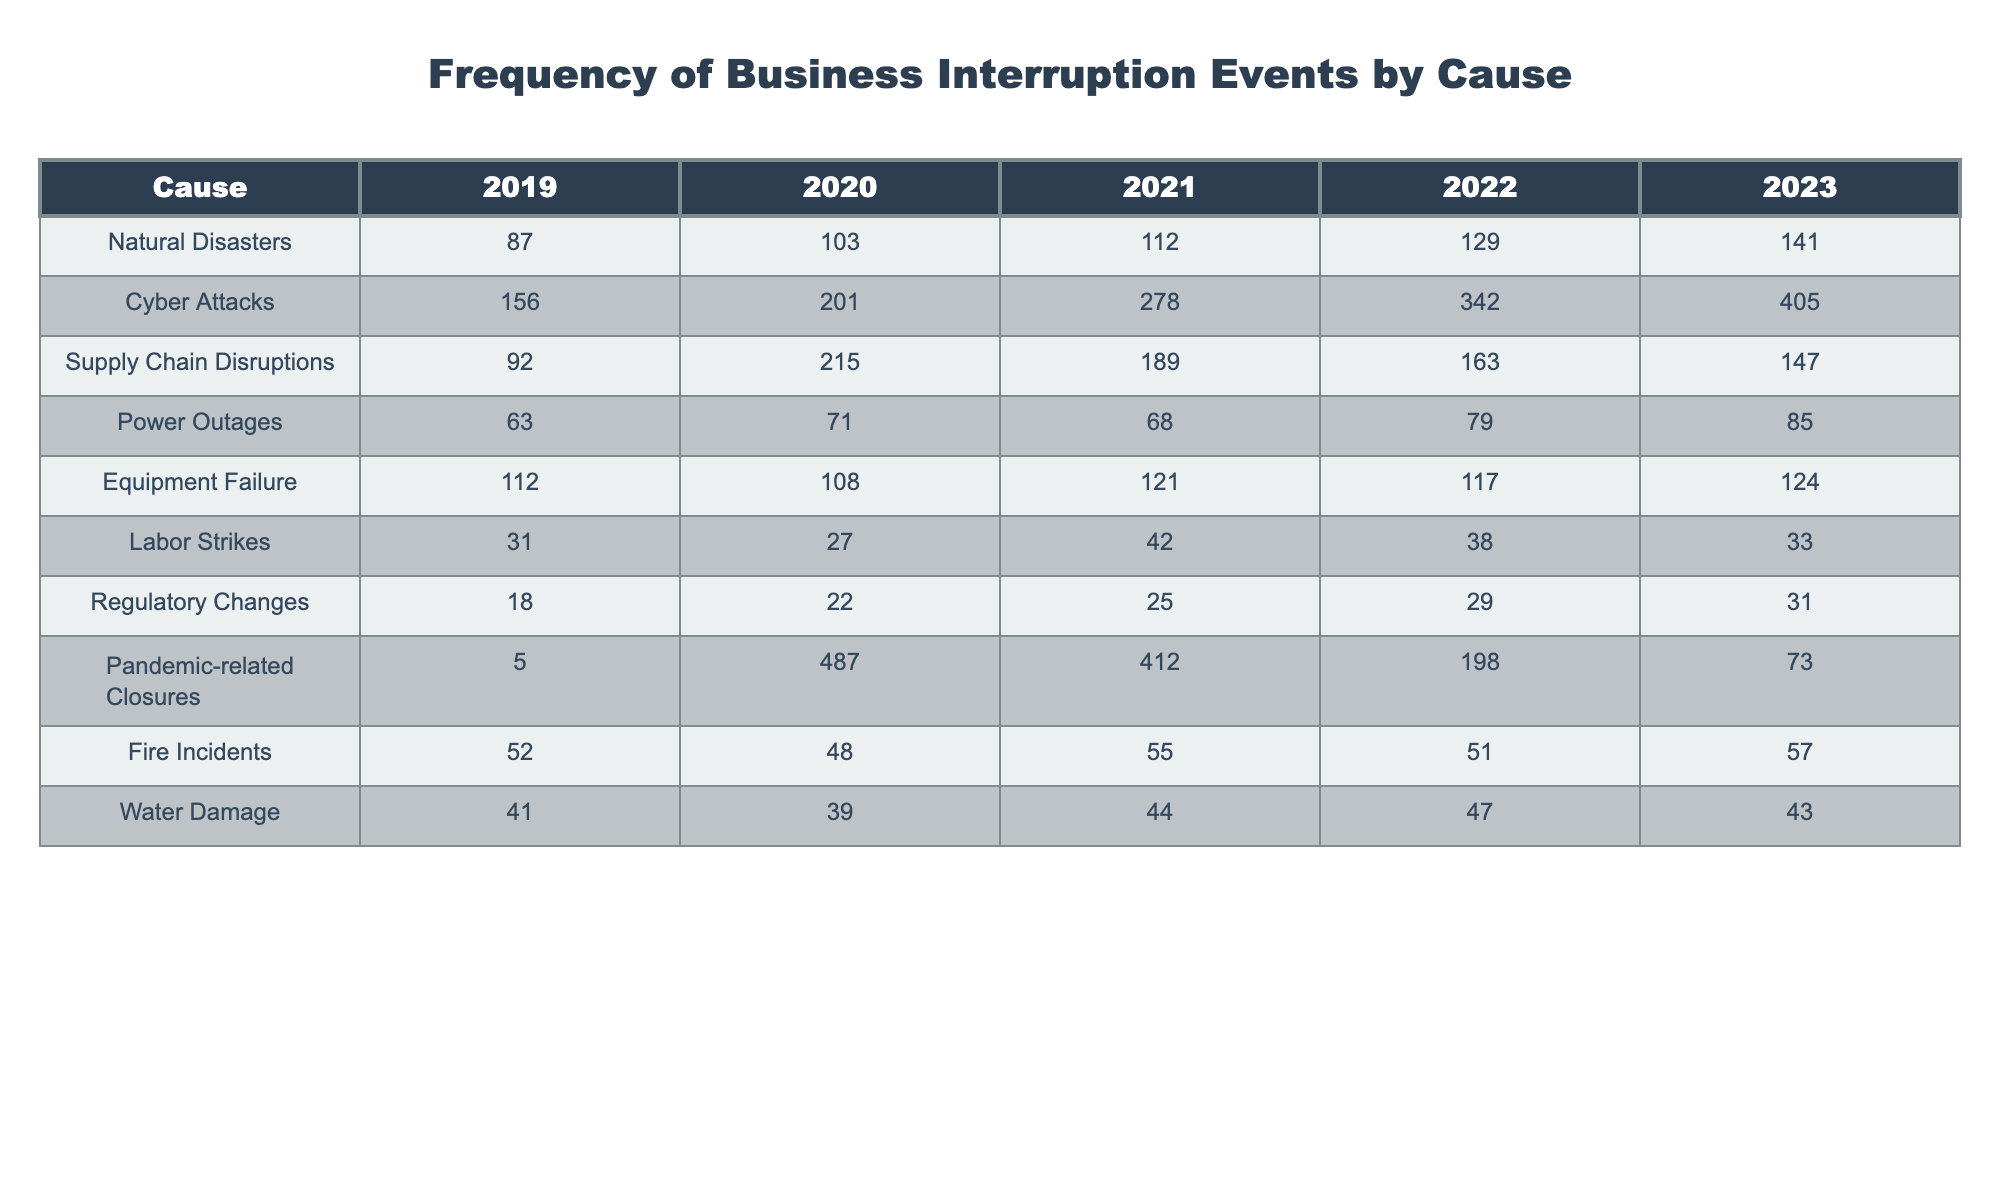What was the total frequency of Cyber Attacks from 2019 to 2023? To find the total frequency of Cyber Attacks, we sum the values for each year: 156 + 201 + 278 + 342 + 405 = 1382.
Answer: 1382 In which year did Supply Chain Disruptions peak? By looking at the values for Supply Chain Disruptions, the highest value is in 2020 with 215 events.
Answer: 2020 How many more Natural Disasters occurred in 2023 compared to 2019? We subtract the frequency of Natural Disasters in 2019 (87) from that in 2023 (141): 141 - 87 = 54.
Answer: 54 Was there a decline in the number of Pandemic-related Closures from 2020 to 2023? In 2020, there were 487 closures, and in 2023 there were 73 closures. Since 73 is less than 487, there was a decline.
Answer: Yes What is the average frequency of Equipment Failures over the five years? We have the values 112, 108, 121, 117, and 124. Summing them gives 112 + 108 + 121 + 117 + 124 = 582. There are 5 years, so the average is 582 / 5 = 116.4.
Answer: 116.4 Which cause of business interruption had the highest frequency in 2023? By examining the values for 2023, Cyber Attacks had the highest frequency with 405 occurrences, compared to other causes.
Answer: Cyber Attacks What was the total frequency of all events in 2022? Summing the frequencies for all causes in 2022 gives: 129 + 342 + 163 + 79 + 117 + 38 + 29 + 198 + 51 + 47 = 1393.
Answer: 1393 How many more events were caused by Natural Disasters than by Labor Strikes in 2021? In 2021, Natural Disasters had 112 events and Labor Strikes had 42. Therefore, 112 - 42 = 70 more events were caused by Natural Disasters.
Answer: 70 Is the frequency of Fire Incidents generally increasing or decreasing over the five years? The values for Fire Incidents are 52, 48, 55, 51, and 57. Observing the trend, the values do not consistently increase or decrease. However, from 2019 to 2023, it had slight fluctuations but ended higher in 2023 compared to earlier years.
Answer: Increasing What is the median value of Supply Chain Disruptions over the five years? The values for Supply Chain Disruptions are 92, 215, 189, 163, and 147. Sorting them gives 92, 147, 163, 189, 215. The median, which is the middle value, is 163.
Answer: 163 What is the difference in frequency of Equipment Failures between the years 2020 and 2023? In 2020, there were 108 Equipment Failures, and in 2023 there were 124. So, we calculate 124 - 108 = 16 more failures in 2023.
Answer: 16 